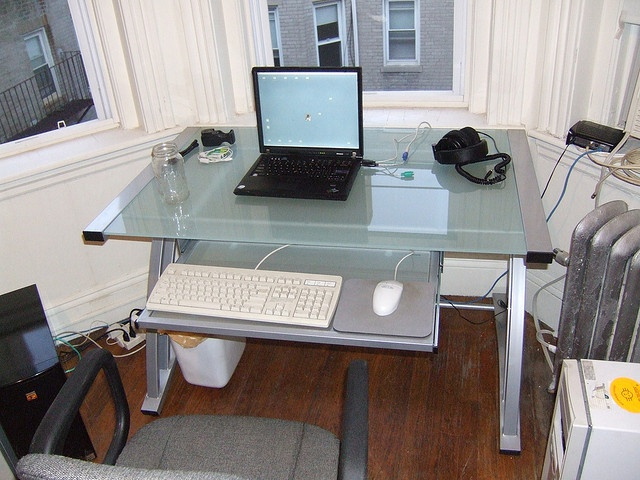Describe the objects in this image and their specific colors. I can see chair in gray, black, darkgray, and maroon tones, laptop in gray, black, lightblue, and lightgray tones, keyboard in gray, lightgray, and darkgray tones, keyboard in gray and black tones, and mouse in gray, lightgray, and darkgray tones in this image. 